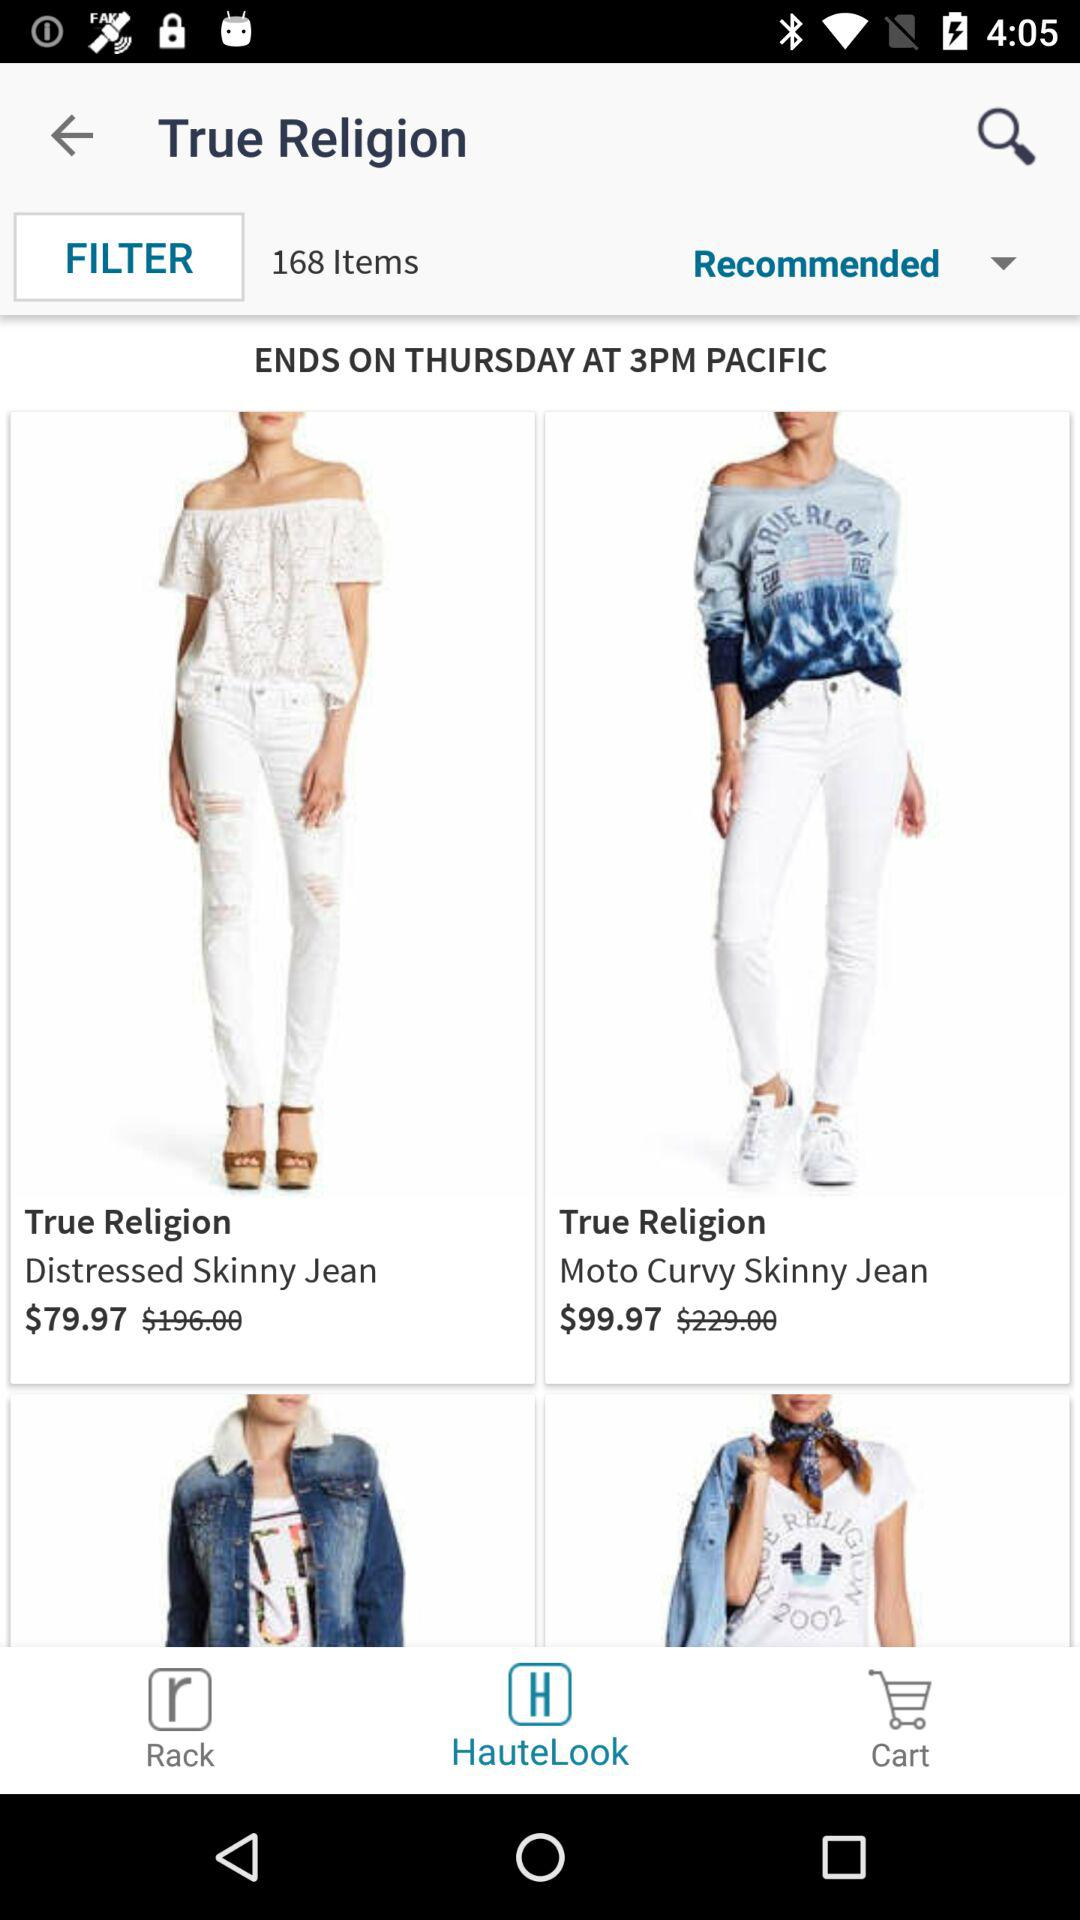How many items are on sale?
Answer the question using a single word or phrase. 168 